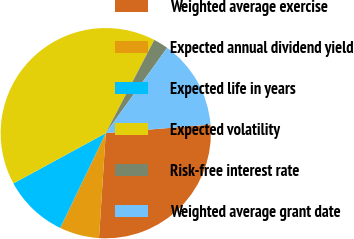Convert chart. <chart><loc_0><loc_0><loc_500><loc_500><pie_chart><fcel>Weighted average exercise<fcel>Expected annual dividend yield<fcel>Expected life in years<fcel>Expected volatility<fcel>Risk-free interest rate<fcel>Weighted average grant date<nl><fcel>27.34%<fcel>6.11%<fcel>9.94%<fcel>40.58%<fcel>2.28%<fcel>13.77%<nl></chart> 